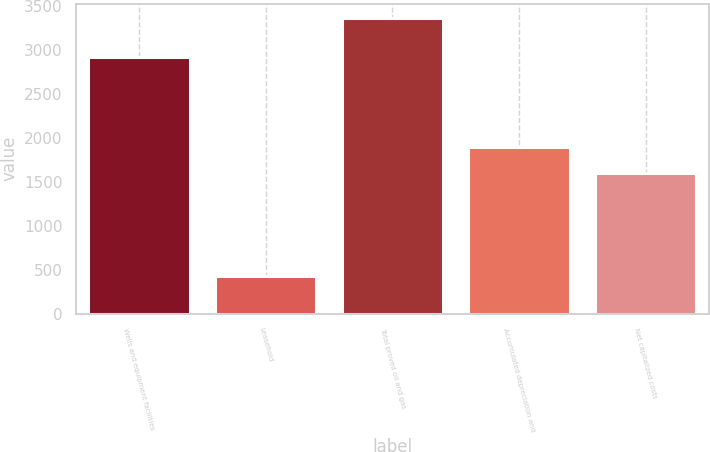<chart> <loc_0><loc_0><loc_500><loc_500><bar_chart><fcel>Wells and equipment facilities<fcel>Leasehold<fcel>Total proved oil and gas<fcel>Accumulated depreciation and<fcel>Net capitalized costs<nl><fcel>2920.7<fcel>433.5<fcel>3354.2<fcel>1892.47<fcel>1600.4<nl></chart> 